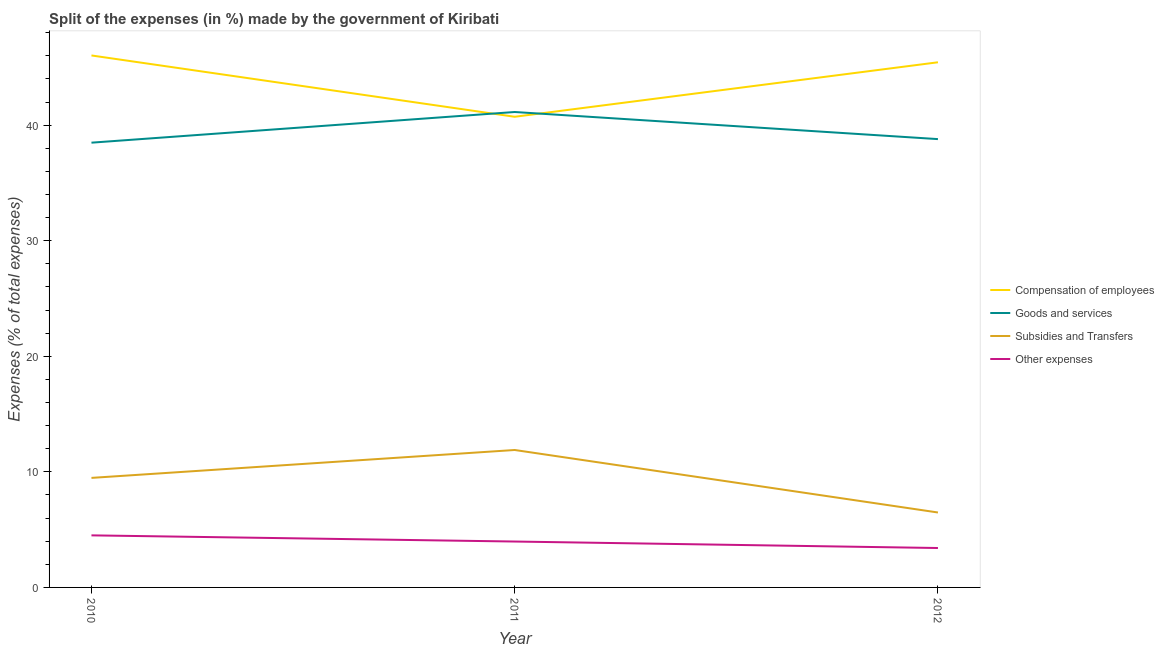Does the line corresponding to percentage of amount spent on other expenses intersect with the line corresponding to percentage of amount spent on goods and services?
Give a very brief answer. No. Is the number of lines equal to the number of legend labels?
Your response must be concise. Yes. What is the percentage of amount spent on subsidies in 2012?
Your answer should be compact. 6.48. Across all years, what is the maximum percentage of amount spent on subsidies?
Provide a short and direct response. 11.89. Across all years, what is the minimum percentage of amount spent on other expenses?
Make the answer very short. 3.41. In which year was the percentage of amount spent on goods and services maximum?
Provide a succinct answer. 2011. What is the total percentage of amount spent on compensation of employees in the graph?
Offer a terse response. 132.2. What is the difference between the percentage of amount spent on other expenses in 2011 and that in 2012?
Offer a very short reply. 0.56. What is the difference between the percentage of amount spent on goods and services in 2011 and the percentage of amount spent on subsidies in 2010?
Ensure brevity in your answer.  31.66. What is the average percentage of amount spent on subsidies per year?
Your response must be concise. 9.28. In the year 2010, what is the difference between the percentage of amount spent on subsidies and percentage of amount spent on compensation of employees?
Give a very brief answer. -36.55. In how many years, is the percentage of amount spent on other expenses greater than 18 %?
Your response must be concise. 0. What is the ratio of the percentage of amount spent on other expenses in 2010 to that in 2011?
Provide a succinct answer. 1.13. Is the percentage of amount spent on goods and services in 2010 less than that in 2012?
Ensure brevity in your answer.  Yes. Is the difference between the percentage of amount spent on compensation of employees in 2010 and 2012 greater than the difference between the percentage of amount spent on subsidies in 2010 and 2012?
Keep it short and to the point. No. What is the difference between the highest and the second highest percentage of amount spent on compensation of employees?
Offer a terse response. 0.59. What is the difference between the highest and the lowest percentage of amount spent on other expenses?
Your answer should be compact. 1.1. Does the percentage of amount spent on goods and services monotonically increase over the years?
Keep it short and to the point. No. Is the percentage of amount spent on other expenses strictly less than the percentage of amount spent on compensation of employees over the years?
Provide a short and direct response. Yes. Does the graph contain any zero values?
Offer a terse response. No. Where does the legend appear in the graph?
Offer a terse response. Center right. How are the legend labels stacked?
Make the answer very short. Vertical. What is the title of the graph?
Provide a succinct answer. Split of the expenses (in %) made by the government of Kiribati. Does "WFP" appear as one of the legend labels in the graph?
Ensure brevity in your answer.  No. What is the label or title of the X-axis?
Keep it short and to the point. Year. What is the label or title of the Y-axis?
Keep it short and to the point. Expenses (% of total expenses). What is the Expenses (% of total expenses) in Compensation of employees in 2010?
Keep it short and to the point. 46.03. What is the Expenses (% of total expenses) of Goods and services in 2010?
Ensure brevity in your answer.  38.49. What is the Expenses (% of total expenses) of Subsidies and Transfers in 2010?
Provide a succinct answer. 9.48. What is the Expenses (% of total expenses) in Other expenses in 2010?
Keep it short and to the point. 4.51. What is the Expenses (% of total expenses) of Compensation of employees in 2011?
Ensure brevity in your answer.  40.73. What is the Expenses (% of total expenses) in Goods and services in 2011?
Provide a succinct answer. 41.14. What is the Expenses (% of total expenses) of Subsidies and Transfers in 2011?
Provide a short and direct response. 11.89. What is the Expenses (% of total expenses) in Other expenses in 2011?
Provide a short and direct response. 3.97. What is the Expenses (% of total expenses) of Compensation of employees in 2012?
Ensure brevity in your answer.  45.44. What is the Expenses (% of total expenses) in Goods and services in 2012?
Make the answer very short. 38.79. What is the Expenses (% of total expenses) in Subsidies and Transfers in 2012?
Offer a very short reply. 6.48. What is the Expenses (% of total expenses) of Other expenses in 2012?
Your response must be concise. 3.41. Across all years, what is the maximum Expenses (% of total expenses) of Compensation of employees?
Offer a terse response. 46.03. Across all years, what is the maximum Expenses (% of total expenses) in Goods and services?
Ensure brevity in your answer.  41.14. Across all years, what is the maximum Expenses (% of total expenses) of Subsidies and Transfers?
Make the answer very short. 11.89. Across all years, what is the maximum Expenses (% of total expenses) of Other expenses?
Give a very brief answer. 4.51. Across all years, what is the minimum Expenses (% of total expenses) in Compensation of employees?
Your response must be concise. 40.73. Across all years, what is the minimum Expenses (% of total expenses) of Goods and services?
Offer a terse response. 38.49. Across all years, what is the minimum Expenses (% of total expenses) of Subsidies and Transfers?
Offer a very short reply. 6.48. Across all years, what is the minimum Expenses (% of total expenses) of Other expenses?
Offer a very short reply. 3.41. What is the total Expenses (% of total expenses) of Compensation of employees in the graph?
Provide a short and direct response. 132.2. What is the total Expenses (% of total expenses) in Goods and services in the graph?
Your response must be concise. 118.42. What is the total Expenses (% of total expenses) of Subsidies and Transfers in the graph?
Give a very brief answer. 27.85. What is the total Expenses (% of total expenses) of Other expenses in the graph?
Keep it short and to the point. 11.89. What is the difference between the Expenses (% of total expenses) in Compensation of employees in 2010 and that in 2011?
Keep it short and to the point. 5.31. What is the difference between the Expenses (% of total expenses) in Goods and services in 2010 and that in 2011?
Offer a terse response. -2.65. What is the difference between the Expenses (% of total expenses) in Subsidies and Transfers in 2010 and that in 2011?
Give a very brief answer. -2.41. What is the difference between the Expenses (% of total expenses) of Other expenses in 2010 and that in 2011?
Your answer should be compact. 0.53. What is the difference between the Expenses (% of total expenses) of Compensation of employees in 2010 and that in 2012?
Ensure brevity in your answer.  0.59. What is the difference between the Expenses (% of total expenses) in Goods and services in 2010 and that in 2012?
Ensure brevity in your answer.  -0.31. What is the difference between the Expenses (% of total expenses) in Subsidies and Transfers in 2010 and that in 2012?
Keep it short and to the point. 2.99. What is the difference between the Expenses (% of total expenses) in Other expenses in 2010 and that in 2012?
Provide a succinct answer. 1.1. What is the difference between the Expenses (% of total expenses) of Compensation of employees in 2011 and that in 2012?
Give a very brief answer. -4.72. What is the difference between the Expenses (% of total expenses) of Goods and services in 2011 and that in 2012?
Keep it short and to the point. 2.35. What is the difference between the Expenses (% of total expenses) in Subsidies and Transfers in 2011 and that in 2012?
Give a very brief answer. 5.41. What is the difference between the Expenses (% of total expenses) in Other expenses in 2011 and that in 2012?
Your response must be concise. 0.56. What is the difference between the Expenses (% of total expenses) in Compensation of employees in 2010 and the Expenses (% of total expenses) in Goods and services in 2011?
Your response must be concise. 4.89. What is the difference between the Expenses (% of total expenses) in Compensation of employees in 2010 and the Expenses (% of total expenses) in Subsidies and Transfers in 2011?
Keep it short and to the point. 34.14. What is the difference between the Expenses (% of total expenses) of Compensation of employees in 2010 and the Expenses (% of total expenses) of Other expenses in 2011?
Provide a succinct answer. 42.06. What is the difference between the Expenses (% of total expenses) in Goods and services in 2010 and the Expenses (% of total expenses) in Subsidies and Transfers in 2011?
Provide a succinct answer. 26.59. What is the difference between the Expenses (% of total expenses) of Goods and services in 2010 and the Expenses (% of total expenses) of Other expenses in 2011?
Offer a terse response. 34.51. What is the difference between the Expenses (% of total expenses) of Subsidies and Transfers in 2010 and the Expenses (% of total expenses) of Other expenses in 2011?
Your answer should be compact. 5.51. What is the difference between the Expenses (% of total expenses) in Compensation of employees in 2010 and the Expenses (% of total expenses) in Goods and services in 2012?
Your response must be concise. 7.24. What is the difference between the Expenses (% of total expenses) in Compensation of employees in 2010 and the Expenses (% of total expenses) in Subsidies and Transfers in 2012?
Offer a very short reply. 39.55. What is the difference between the Expenses (% of total expenses) of Compensation of employees in 2010 and the Expenses (% of total expenses) of Other expenses in 2012?
Offer a very short reply. 42.62. What is the difference between the Expenses (% of total expenses) of Goods and services in 2010 and the Expenses (% of total expenses) of Subsidies and Transfers in 2012?
Give a very brief answer. 32. What is the difference between the Expenses (% of total expenses) in Goods and services in 2010 and the Expenses (% of total expenses) in Other expenses in 2012?
Offer a very short reply. 35.08. What is the difference between the Expenses (% of total expenses) in Subsidies and Transfers in 2010 and the Expenses (% of total expenses) in Other expenses in 2012?
Offer a terse response. 6.07. What is the difference between the Expenses (% of total expenses) in Compensation of employees in 2011 and the Expenses (% of total expenses) in Goods and services in 2012?
Offer a terse response. 1.93. What is the difference between the Expenses (% of total expenses) in Compensation of employees in 2011 and the Expenses (% of total expenses) in Subsidies and Transfers in 2012?
Make the answer very short. 34.24. What is the difference between the Expenses (% of total expenses) of Compensation of employees in 2011 and the Expenses (% of total expenses) of Other expenses in 2012?
Provide a succinct answer. 37.32. What is the difference between the Expenses (% of total expenses) of Goods and services in 2011 and the Expenses (% of total expenses) of Subsidies and Transfers in 2012?
Offer a terse response. 34.66. What is the difference between the Expenses (% of total expenses) in Goods and services in 2011 and the Expenses (% of total expenses) in Other expenses in 2012?
Provide a succinct answer. 37.73. What is the difference between the Expenses (% of total expenses) of Subsidies and Transfers in 2011 and the Expenses (% of total expenses) of Other expenses in 2012?
Ensure brevity in your answer.  8.48. What is the average Expenses (% of total expenses) of Compensation of employees per year?
Ensure brevity in your answer.  44.07. What is the average Expenses (% of total expenses) of Goods and services per year?
Make the answer very short. 39.47. What is the average Expenses (% of total expenses) of Subsidies and Transfers per year?
Keep it short and to the point. 9.29. What is the average Expenses (% of total expenses) in Other expenses per year?
Your answer should be compact. 3.96. In the year 2010, what is the difference between the Expenses (% of total expenses) in Compensation of employees and Expenses (% of total expenses) in Goods and services?
Your answer should be very brief. 7.55. In the year 2010, what is the difference between the Expenses (% of total expenses) of Compensation of employees and Expenses (% of total expenses) of Subsidies and Transfers?
Give a very brief answer. 36.55. In the year 2010, what is the difference between the Expenses (% of total expenses) of Compensation of employees and Expenses (% of total expenses) of Other expenses?
Keep it short and to the point. 41.53. In the year 2010, what is the difference between the Expenses (% of total expenses) in Goods and services and Expenses (% of total expenses) in Subsidies and Transfers?
Offer a very short reply. 29.01. In the year 2010, what is the difference between the Expenses (% of total expenses) in Goods and services and Expenses (% of total expenses) in Other expenses?
Your answer should be very brief. 33.98. In the year 2010, what is the difference between the Expenses (% of total expenses) in Subsidies and Transfers and Expenses (% of total expenses) in Other expenses?
Provide a short and direct response. 4.97. In the year 2011, what is the difference between the Expenses (% of total expenses) of Compensation of employees and Expenses (% of total expenses) of Goods and services?
Keep it short and to the point. -0.41. In the year 2011, what is the difference between the Expenses (% of total expenses) of Compensation of employees and Expenses (% of total expenses) of Subsidies and Transfers?
Offer a very short reply. 28.83. In the year 2011, what is the difference between the Expenses (% of total expenses) in Compensation of employees and Expenses (% of total expenses) in Other expenses?
Ensure brevity in your answer.  36.75. In the year 2011, what is the difference between the Expenses (% of total expenses) in Goods and services and Expenses (% of total expenses) in Subsidies and Transfers?
Give a very brief answer. 29.25. In the year 2011, what is the difference between the Expenses (% of total expenses) in Goods and services and Expenses (% of total expenses) in Other expenses?
Provide a succinct answer. 37.17. In the year 2011, what is the difference between the Expenses (% of total expenses) of Subsidies and Transfers and Expenses (% of total expenses) of Other expenses?
Provide a succinct answer. 7.92. In the year 2012, what is the difference between the Expenses (% of total expenses) of Compensation of employees and Expenses (% of total expenses) of Goods and services?
Make the answer very short. 6.65. In the year 2012, what is the difference between the Expenses (% of total expenses) of Compensation of employees and Expenses (% of total expenses) of Subsidies and Transfers?
Your response must be concise. 38.96. In the year 2012, what is the difference between the Expenses (% of total expenses) in Compensation of employees and Expenses (% of total expenses) in Other expenses?
Provide a succinct answer. 42.03. In the year 2012, what is the difference between the Expenses (% of total expenses) in Goods and services and Expenses (% of total expenses) in Subsidies and Transfers?
Offer a terse response. 32.31. In the year 2012, what is the difference between the Expenses (% of total expenses) in Goods and services and Expenses (% of total expenses) in Other expenses?
Offer a very short reply. 35.38. In the year 2012, what is the difference between the Expenses (% of total expenses) in Subsidies and Transfers and Expenses (% of total expenses) in Other expenses?
Give a very brief answer. 3.07. What is the ratio of the Expenses (% of total expenses) of Compensation of employees in 2010 to that in 2011?
Give a very brief answer. 1.13. What is the ratio of the Expenses (% of total expenses) in Goods and services in 2010 to that in 2011?
Your answer should be very brief. 0.94. What is the ratio of the Expenses (% of total expenses) of Subsidies and Transfers in 2010 to that in 2011?
Your answer should be compact. 0.8. What is the ratio of the Expenses (% of total expenses) of Other expenses in 2010 to that in 2011?
Provide a short and direct response. 1.13. What is the ratio of the Expenses (% of total expenses) in Compensation of employees in 2010 to that in 2012?
Offer a terse response. 1.01. What is the ratio of the Expenses (% of total expenses) of Subsidies and Transfers in 2010 to that in 2012?
Offer a very short reply. 1.46. What is the ratio of the Expenses (% of total expenses) of Other expenses in 2010 to that in 2012?
Your answer should be very brief. 1.32. What is the ratio of the Expenses (% of total expenses) of Compensation of employees in 2011 to that in 2012?
Give a very brief answer. 0.9. What is the ratio of the Expenses (% of total expenses) in Goods and services in 2011 to that in 2012?
Your answer should be compact. 1.06. What is the ratio of the Expenses (% of total expenses) in Subsidies and Transfers in 2011 to that in 2012?
Your answer should be very brief. 1.83. What is the ratio of the Expenses (% of total expenses) in Other expenses in 2011 to that in 2012?
Provide a short and direct response. 1.16. What is the difference between the highest and the second highest Expenses (% of total expenses) of Compensation of employees?
Provide a succinct answer. 0.59. What is the difference between the highest and the second highest Expenses (% of total expenses) in Goods and services?
Ensure brevity in your answer.  2.35. What is the difference between the highest and the second highest Expenses (% of total expenses) in Subsidies and Transfers?
Keep it short and to the point. 2.41. What is the difference between the highest and the second highest Expenses (% of total expenses) of Other expenses?
Give a very brief answer. 0.53. What is the difference between the highest and the lowest Expenses (% of total expenses) in Compensation of employees?
Keep it short and to the point. 5.31. What is the difference between the highest and the lowest Expenses (% of total expenses) in Goods and services?
Make the answer very short. 2.65. What is the difference between the highest and the lowest Expenses (% of total expenses) in Subsidies and Transfers?
Offer a very short reply. 5.41. What is the difference between the highest and the lowest Expenses (% of total expenses) in Other expenses?
Offer a very short reply. 1.1. 